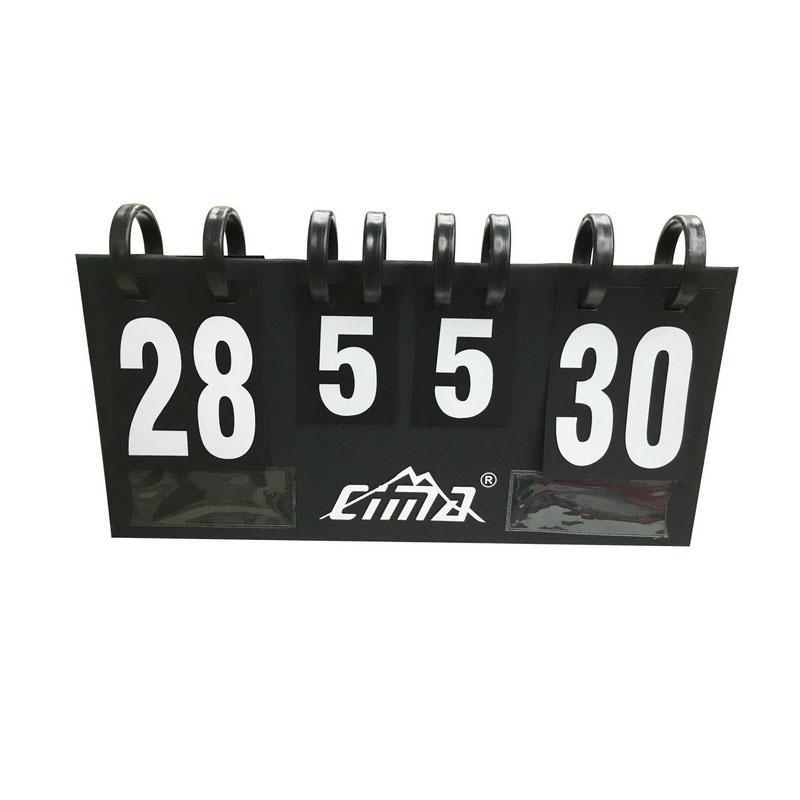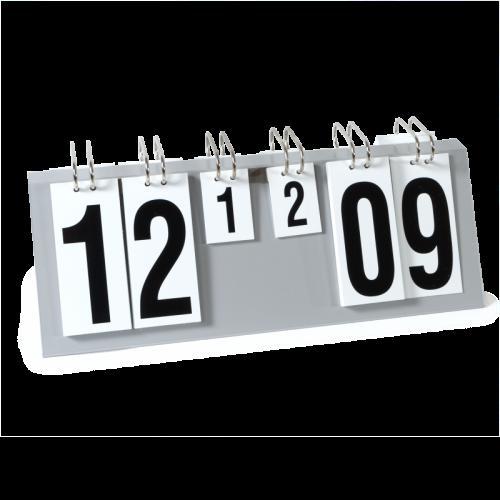The first image is the image on the left, the second image is the image on the right. Analyze the images presented: Is the assertion "In at least one image there is a total of four zeros." valid? Answer yes or no. No. The first image is the image on the left, the second image is the image on the right. For the images shown, is this caption "There are eight rings in the left image." true? Answer yes or no. Yes. 